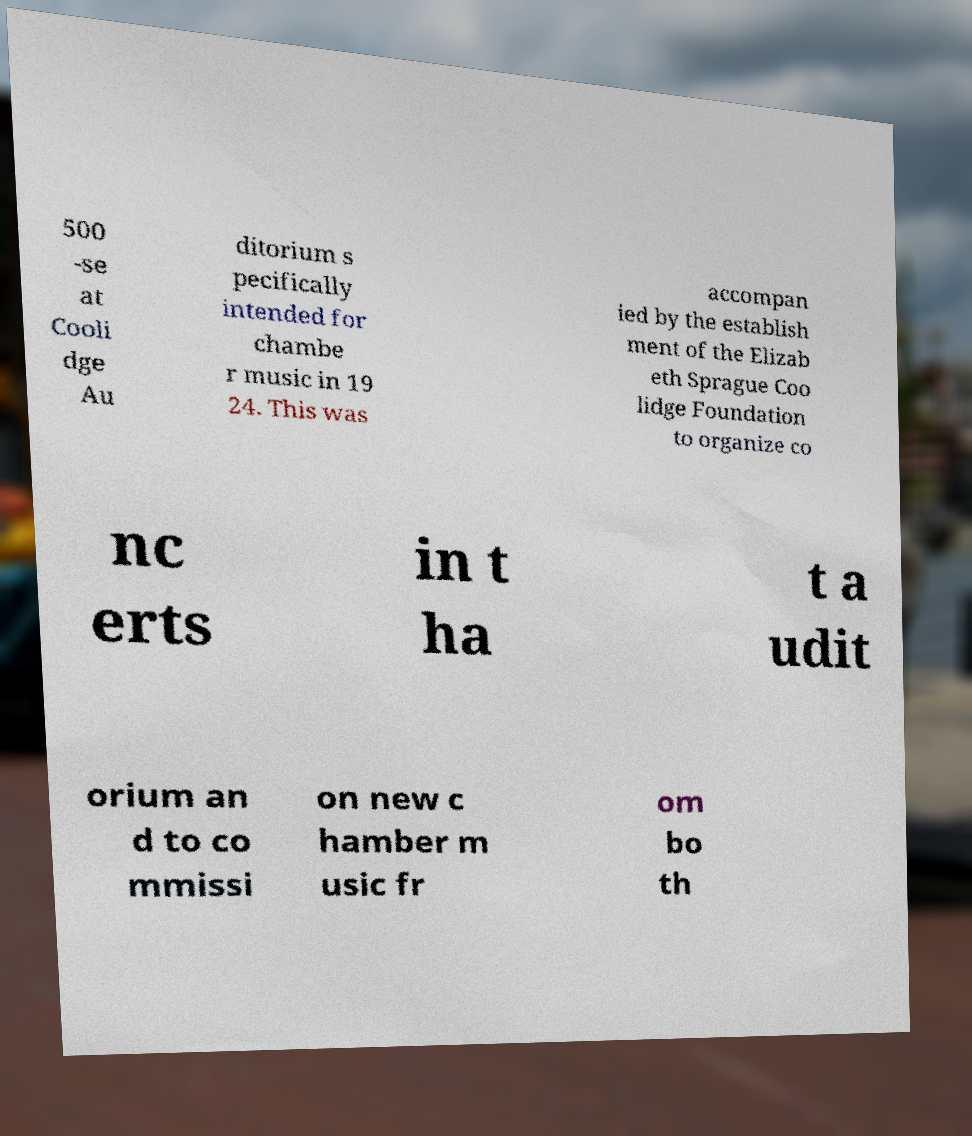Please identify and transcribe the text found in this image. 500 -se at Cooli dge Au ditorium s pecifically intended for chambe r music in 19 24. This was accompan ied by the establish ment of the Elizab eth Sprague Coo lidge Foundation to organize co nc erts in t ha t a udit orium an d to co mmissi on new c hamber m usic fr om bo th 